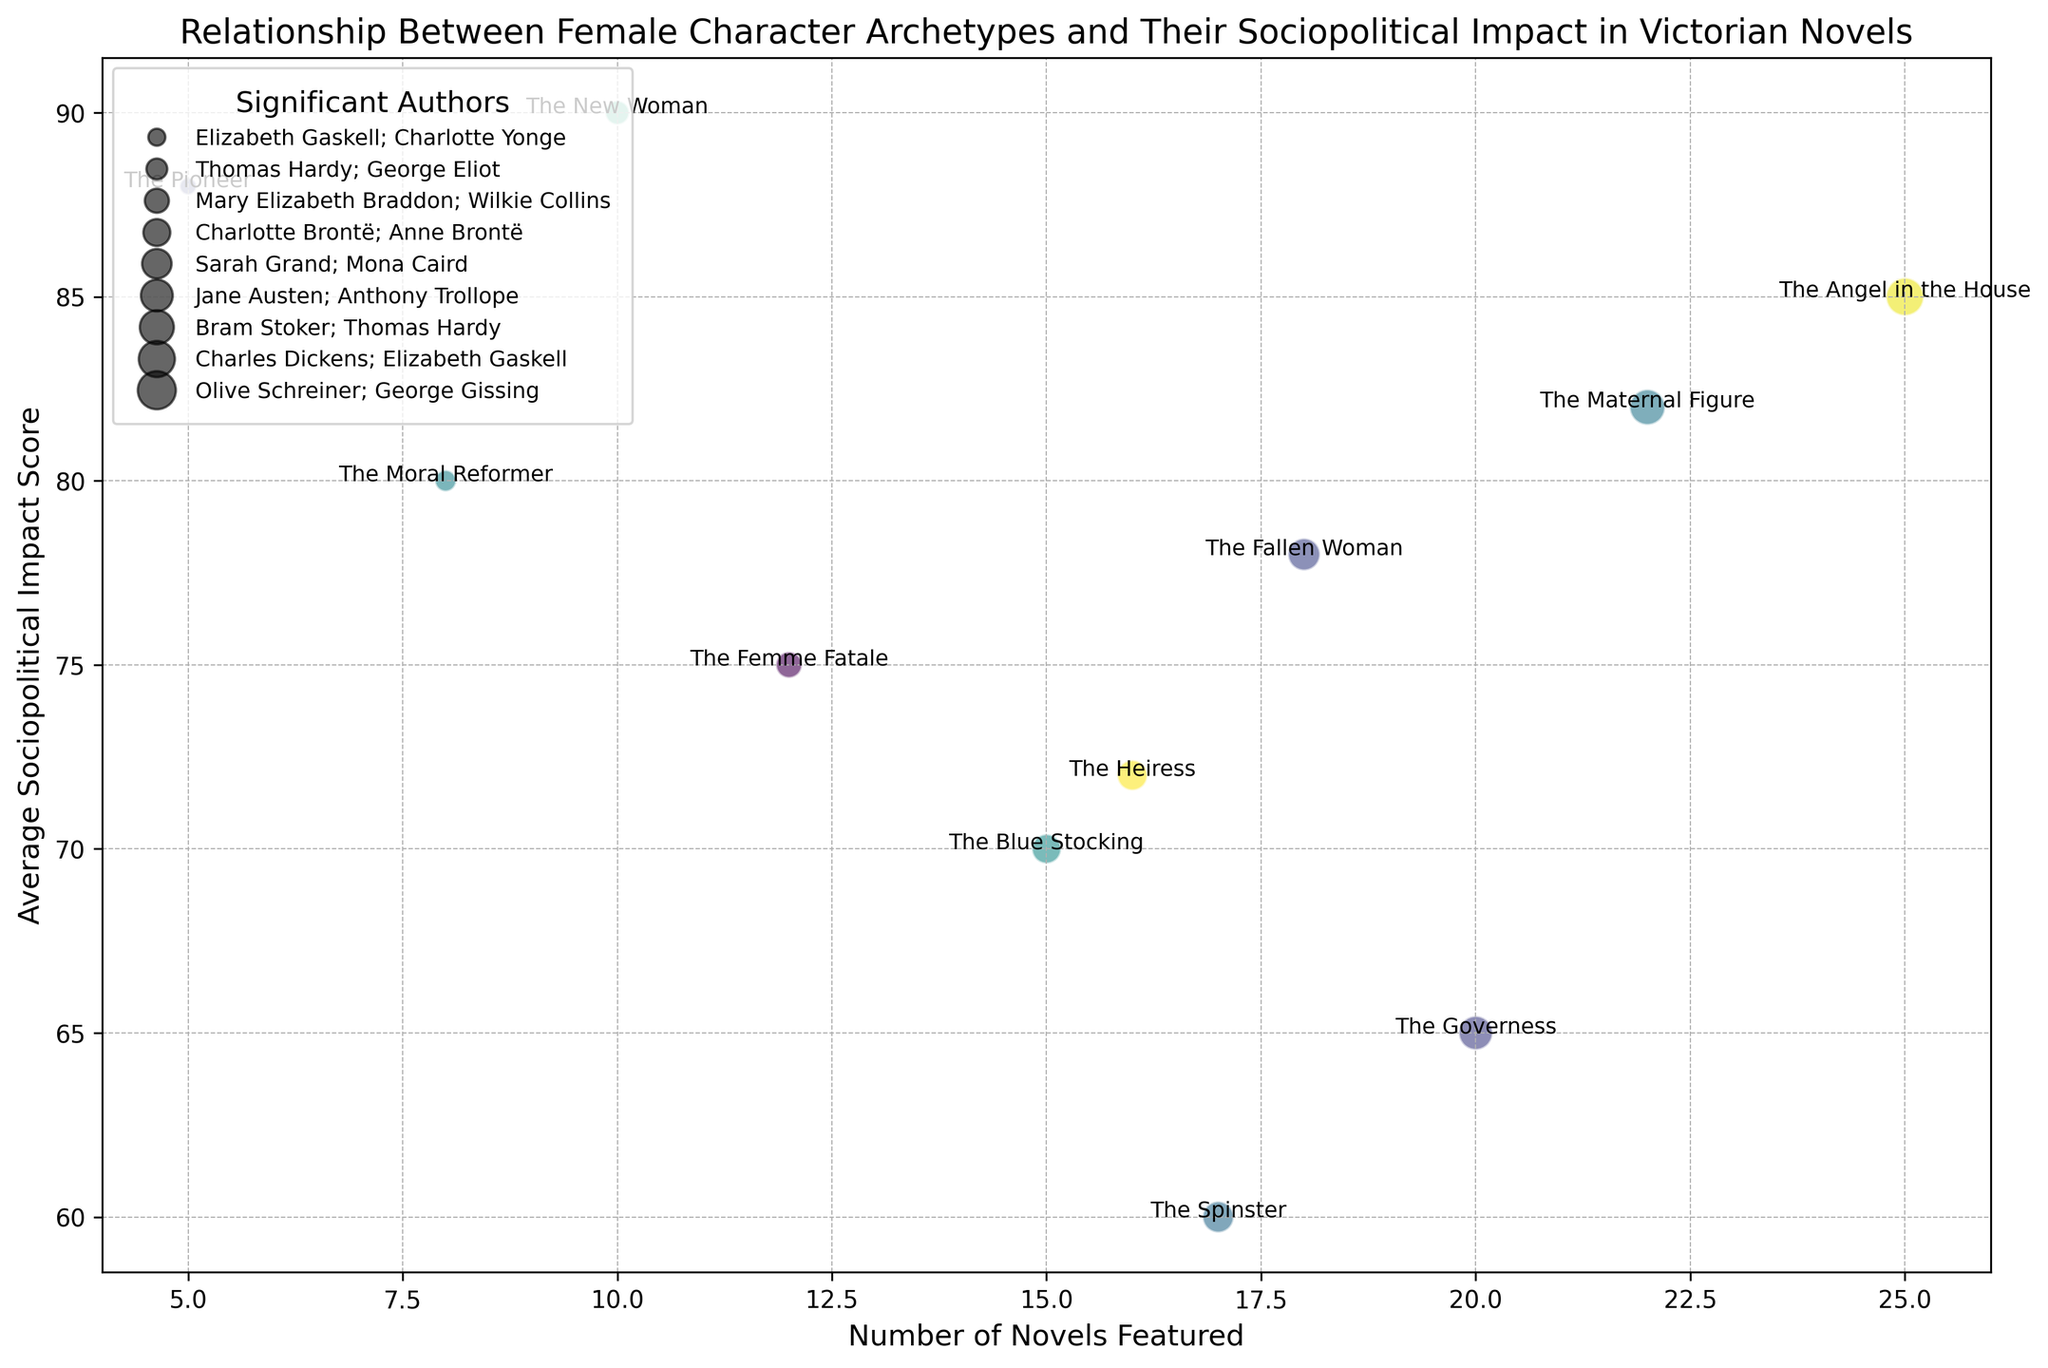What's the average Sociopolitical Impact Score for archetypes featured in more than 15 novels? To solve this, we need to find the average score for "The Angel in the House" (85), "The Governess" (65), and "The Maternal Figure" (82). Sum these scores (85 + 65 + 82 = 232) and divide by the number of archetypes (3), resulting in an average.
Answer: 77.33 Which character archetype has the highest average Sociopolitical Impact Score? Look at the y-axis values to find the highest impact score. "The New Woman" has the highest score at 90.
Answer: The New Woman What is the difference in average Sociopolitical Impact Score between "The Governess" and "The Pioneer"? "The Governess" has a score of 65, and "The Pioneer" has a score of 88. Calculate the difference: 88 - 65 = 23.
Answer: 23 Which archetype is represented by the largest bubble, and how many novels feature it? The largest bubble visually represents "The Angel in the House," which is featured in 25 novels.
Answer: The Angel in the House, 25 Compare the number of novels featuring "The Fallen Woman" and "The Blue Stocking" character archetypes. Which one appears in more novels? "The Fallen Woman" is featured in 18 novels, whereas "The Blue Stocking" is featured in 15 novels. Hence, "The Fallen Woman" appears in more novels.
Answer: The Fallen Woman Rank the top three character archetypes by the number of novels they are featured in. Based on the x-axis values: 1. "The Angel in the House" (25) 2. "The Maternal Figure" (22) 3. "The Governess" (20)
Answer: The Angel in the House, The Maternal Figure, The Governess How does the Sociopolitical Impact Score of "The Blue Stocking" compare to that of "The Femme Fatale"? "The Blue Stocking" has a score of 70, whereas "The Femme Fatale" has a score of 75. "The Femme Fatale" has a higher score.
Answer: The Femme Fatale Identify the character archetypes that have an average Sociopolitical Impact Score above 80. The archetypes with scores above 80 are "The Angel in the House" (85), "The New Woman" (90), "The Pioneer" (88), and "The Maternal Figure" (82).
Answer: The Angel in the House, The New Woman, The Pioneer, The Maternal Figure What is the total number of novels featuring "The Heiress" and "The Spinster"? "The Heiress" is featured in 16 novels, and "The Spinster" in 17. Summing these, 16 + 17 = 33.
Answer: 33 Does "The Angel in the House" archetype have a higher or lower average Sociopolitical Impact Score than "The Pioneer"? "The Angel in the House" has a score of 85, while "The Pioneer" has a score of 88. "The Angel in the House" has a lower score compared to "The Pioneer."
Answer: Lower 